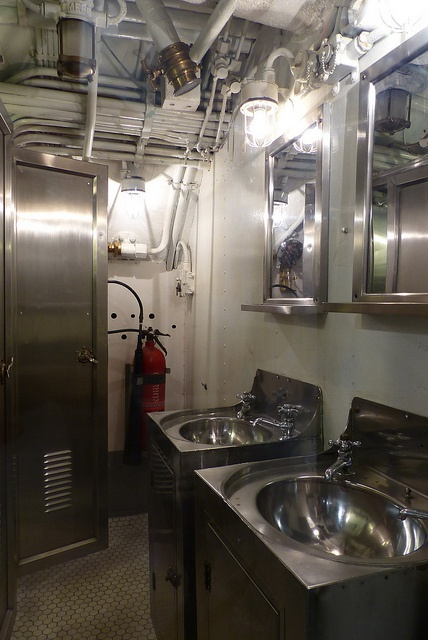Describe the objects in this image and their specific colors. I can see sink in gray and black tones and sink in gray and black tones in this image. 